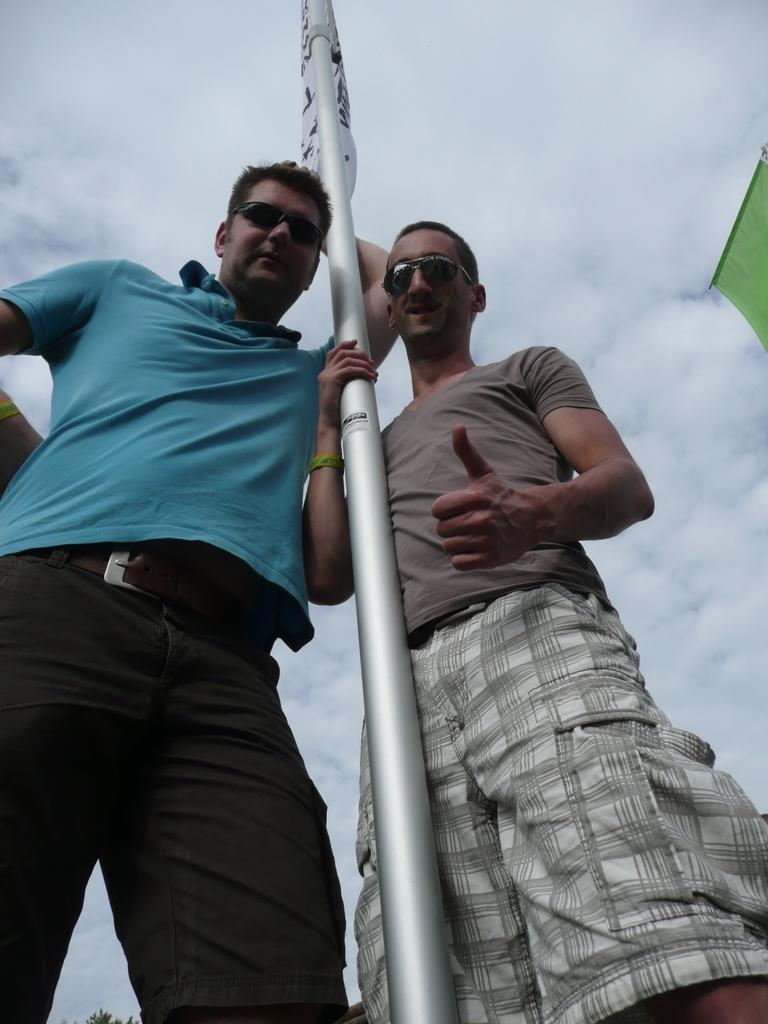What is the person speaking in the image doing? The person speaking is standing at a pole in the center of the image. What can be seen behind the person in the image? There is sky visible in the background of the image. What is the condition of the sky in the image? Clouds are present in the sky. What type of pancake is the person eating in the image? There is no pancake present in the image, and the person is not eating anything. 